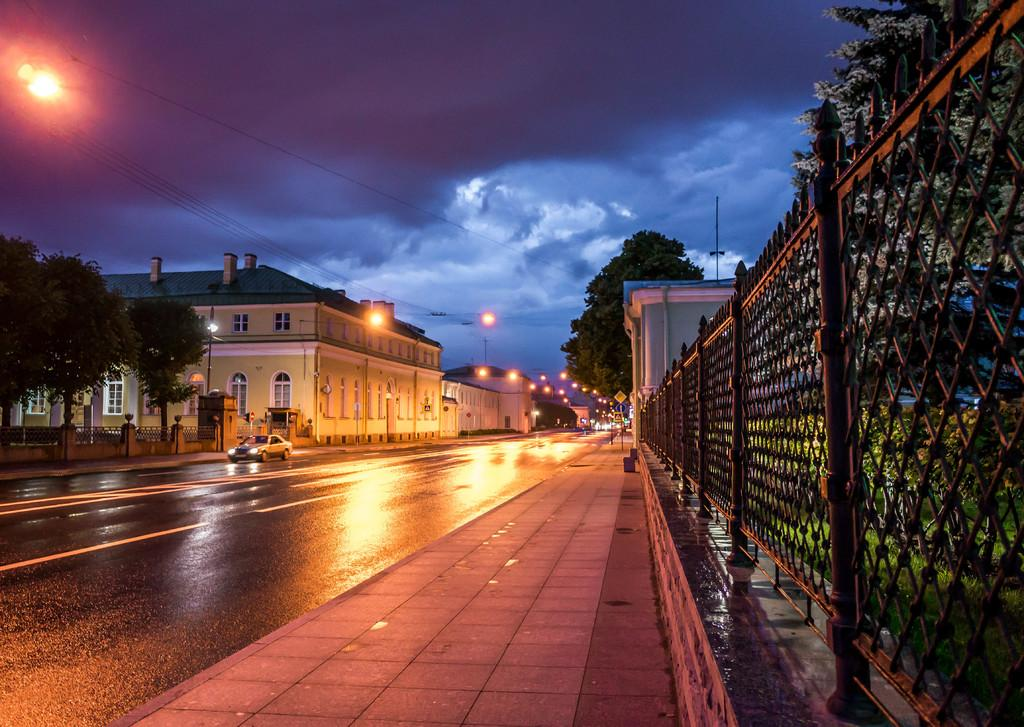What is the main subject of the image? The main subject of the image is a car on the road. What other elements can be seen in the image? There is a footpath, a fence, trees, buildings with windows, lights, and sign boards in the image. What is visible in the background of the image? The sky with clouds is visible in the background of the image. How does the car's digestion process work in the image? Cars do not have a digestion process, as they are not living organisms. The question is not relevant to the image. 